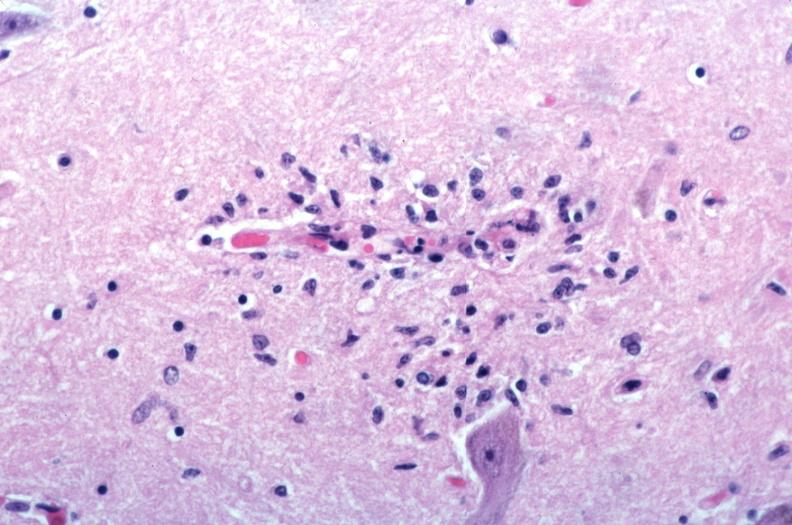what is present?
Answer the question using a single word or phrase. Nervous 